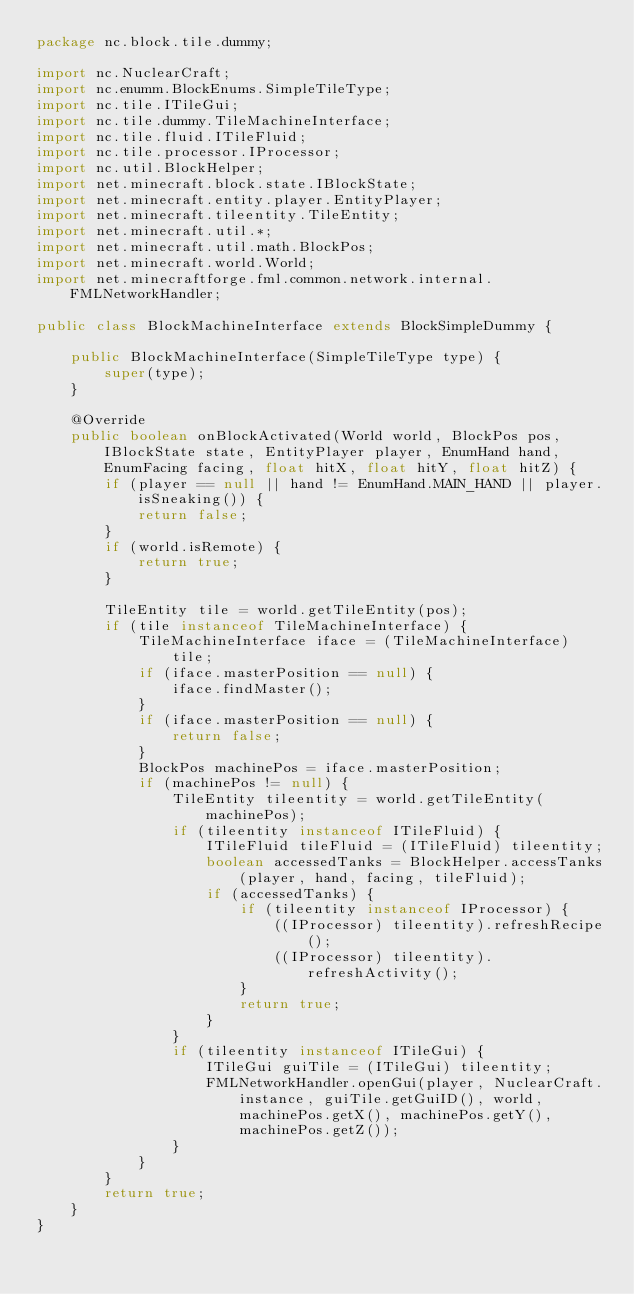Convert code to text. <code><loc_0><loc_0><loc_500><loc_500><_Java_>package nc.block.tile.dummy;

import nc.NuclearCraft;
import nc.enumm.BlockEnums.SimpleTileType;
import nc.tile.ITileGui;
import nc.tile.dummy.TileMachineInterface;
import nc.tile.fluid.ITileFluid;
import nc.tile.processor.IProcessor;
import nc.util.BlockHelper;
import net.minecraft.block.state.IBlockState;
import net.minecraft.entity.player.EntityPlayer;
import net.minecraft.tileentity.TileEntity;
import net.minecraft.util.*;
import net.minecraft.util.math.BlockPos;
import net.minecraft.world.World;
import net.minecraftforge.fml.common.network.internal.FMLNetworkHandler;

public class BlockMachineInterface extends BlockSimpleDummy {
	
	public BlockMachineInterface(SimpleTileType type) {
		super(type);
	}
	
	@Override
	public boolean onBlockActivated(World world, BlockPos pos, IBlockState state, EntityPlayer player, EnumHand hand, EnumFacing facing, float hitX, float hitY, float hitZ) {
		if (player == null || hand != EnumHand.MAIN_HAND || player.isSneaking()) {
			return false;
		}
		if (world.isRemote) {
			return true;
		}
		
		TileEntity tile = world.getTileEntity(pos);
		if (tile instanceof TileMachineInterface) {
			TileMachineInterface iface = (TileMachineInterface) tile;
			if (iface.masterPosition == null) {
				iface.findMaster();
			}
			if (iface.masterPosition == null) {
				return false;
			}
			BlockPos machinePos = iface.masterPosition;
			if (machinePos != null) {
				TileEntity tileentity = world.getTileEntity(machinePos);
				if (tileentity instanceof ITileFluid) {
					ITileFluid tileFluid = (ITileFluid) tileentity;
					boolean accessedTanks = BlockHelper.accessTanks(player, hand, facing, tileFluid);
					if (accessedTanks) {
						if (tileentity instanceof IProcessor) {
							((IProcessor) tileentity).refreshRecipe();
							((IProcessor) tileentity).refreshActivity();
						}
						return true;
					}
				}
				if (tileentity instanceof ITileGui) {
					ITileGui guiTile = (ITileGui) tileentity;
					FMLNetworkHandler.openGui(player, NuclearCraft.instance, guiTile.getGuiID(), world, machinePos.getX(), machinePos.getY(), machinePos.getZ());
				}
			}
		}
		return true;
	}
}
</code> 